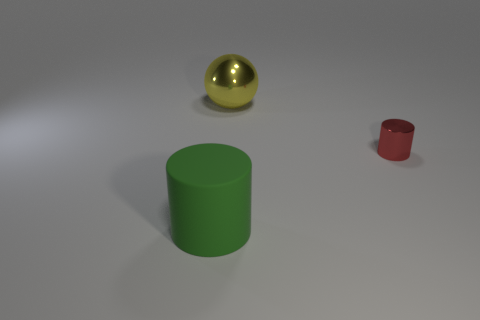Add 1 big yellow shiny spheres. How many objects exist? 4 Subtract all spheres. How many objects are left? 2 Subtract 1 cylinders. How many cylinders are left? 1 Subtract all red balls. Subtract all purple cylinders. How many balls are left? 1 Subtract all brown blocks. How many red cylinders are left? 1 Subtract all red metallic cubes. Subtract all large cylinders. How many objects are left? 2 Add 1 small red metal objects. How many small red metal objects are left? 2 Add 1 large green matte things. How many large green matte things exist? 2 Subtract 0 purple cubes. How many objects are left? 3 